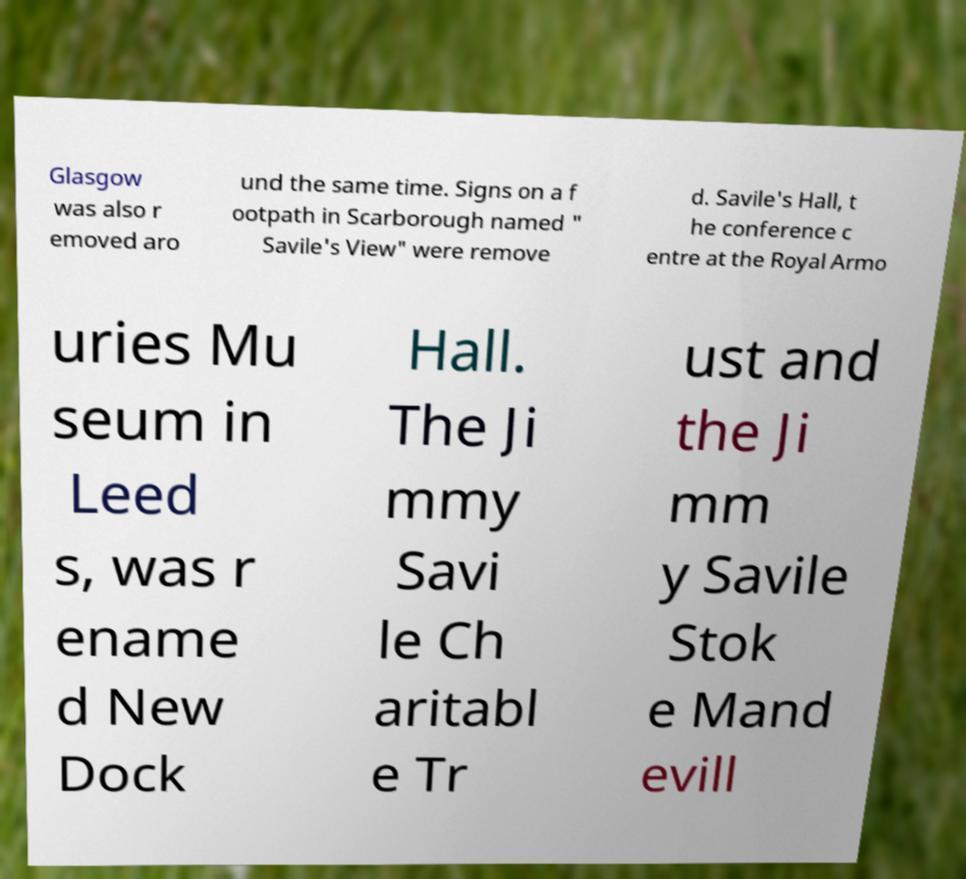Please identify and transcribe the text found in this image. Glasgow was also r emoved aro und the same time. Signs on a f ootpath in Scarborough named " Savile's View" were remove d. Savile's Hall, t he conference c entre at the Royal Armo uries Mu seum in Leed s, was r ename d New Dock Hall. The Ji mmy Savi le Ch aritabl e Tr ust and the Ji mm y Savile Stok e Mand evill 